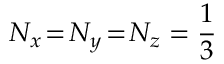Convert formula to latex. <formula><loc_0><loc_0><loc_500><loc_500>N _ { x } \, = \, N _ { y } \, = \, N _ { z } = \frac { 1 } { 3 }</formula> 